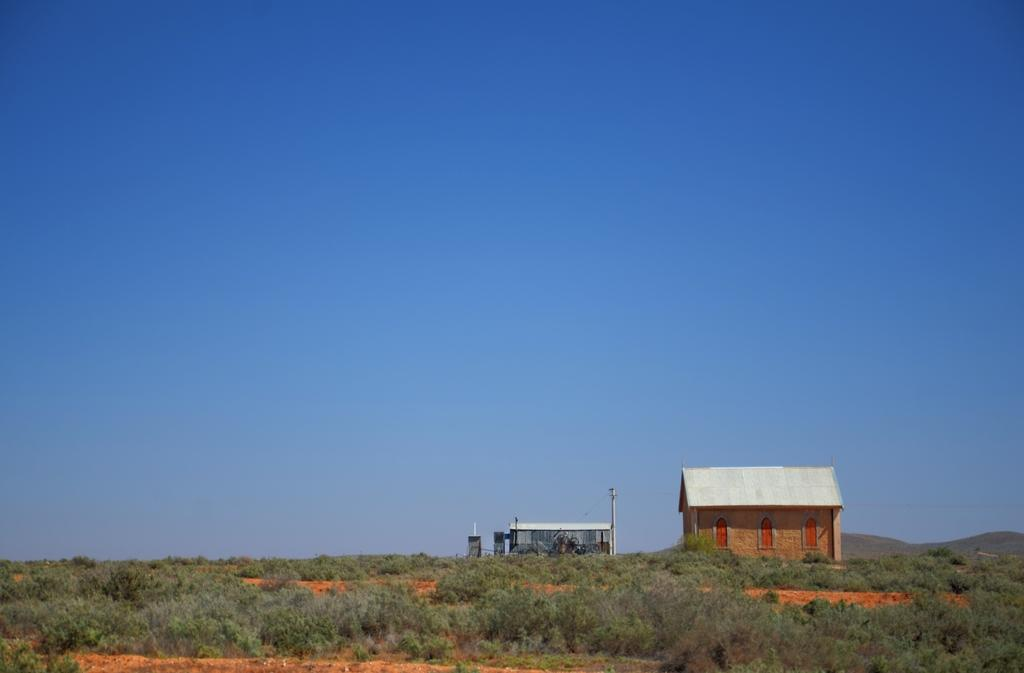What is located in the foreground of the image? There are trees, a house, and a shelter-like structure in the foreground of the image. What can be seen in the background of the image? The sky is visible at the top of the image. How many structures are present in the foreground of the image? There are two structures, a house and a shelter-like structure, in the foreground of the image. What type of berry is hanging from the trees in the image? There is no mention of berries in the image; the trees are not described as having any fruit or berries. Can you see any wires or wire-related objects in the image? There is no mention of wires or wire-related objects in the image. 